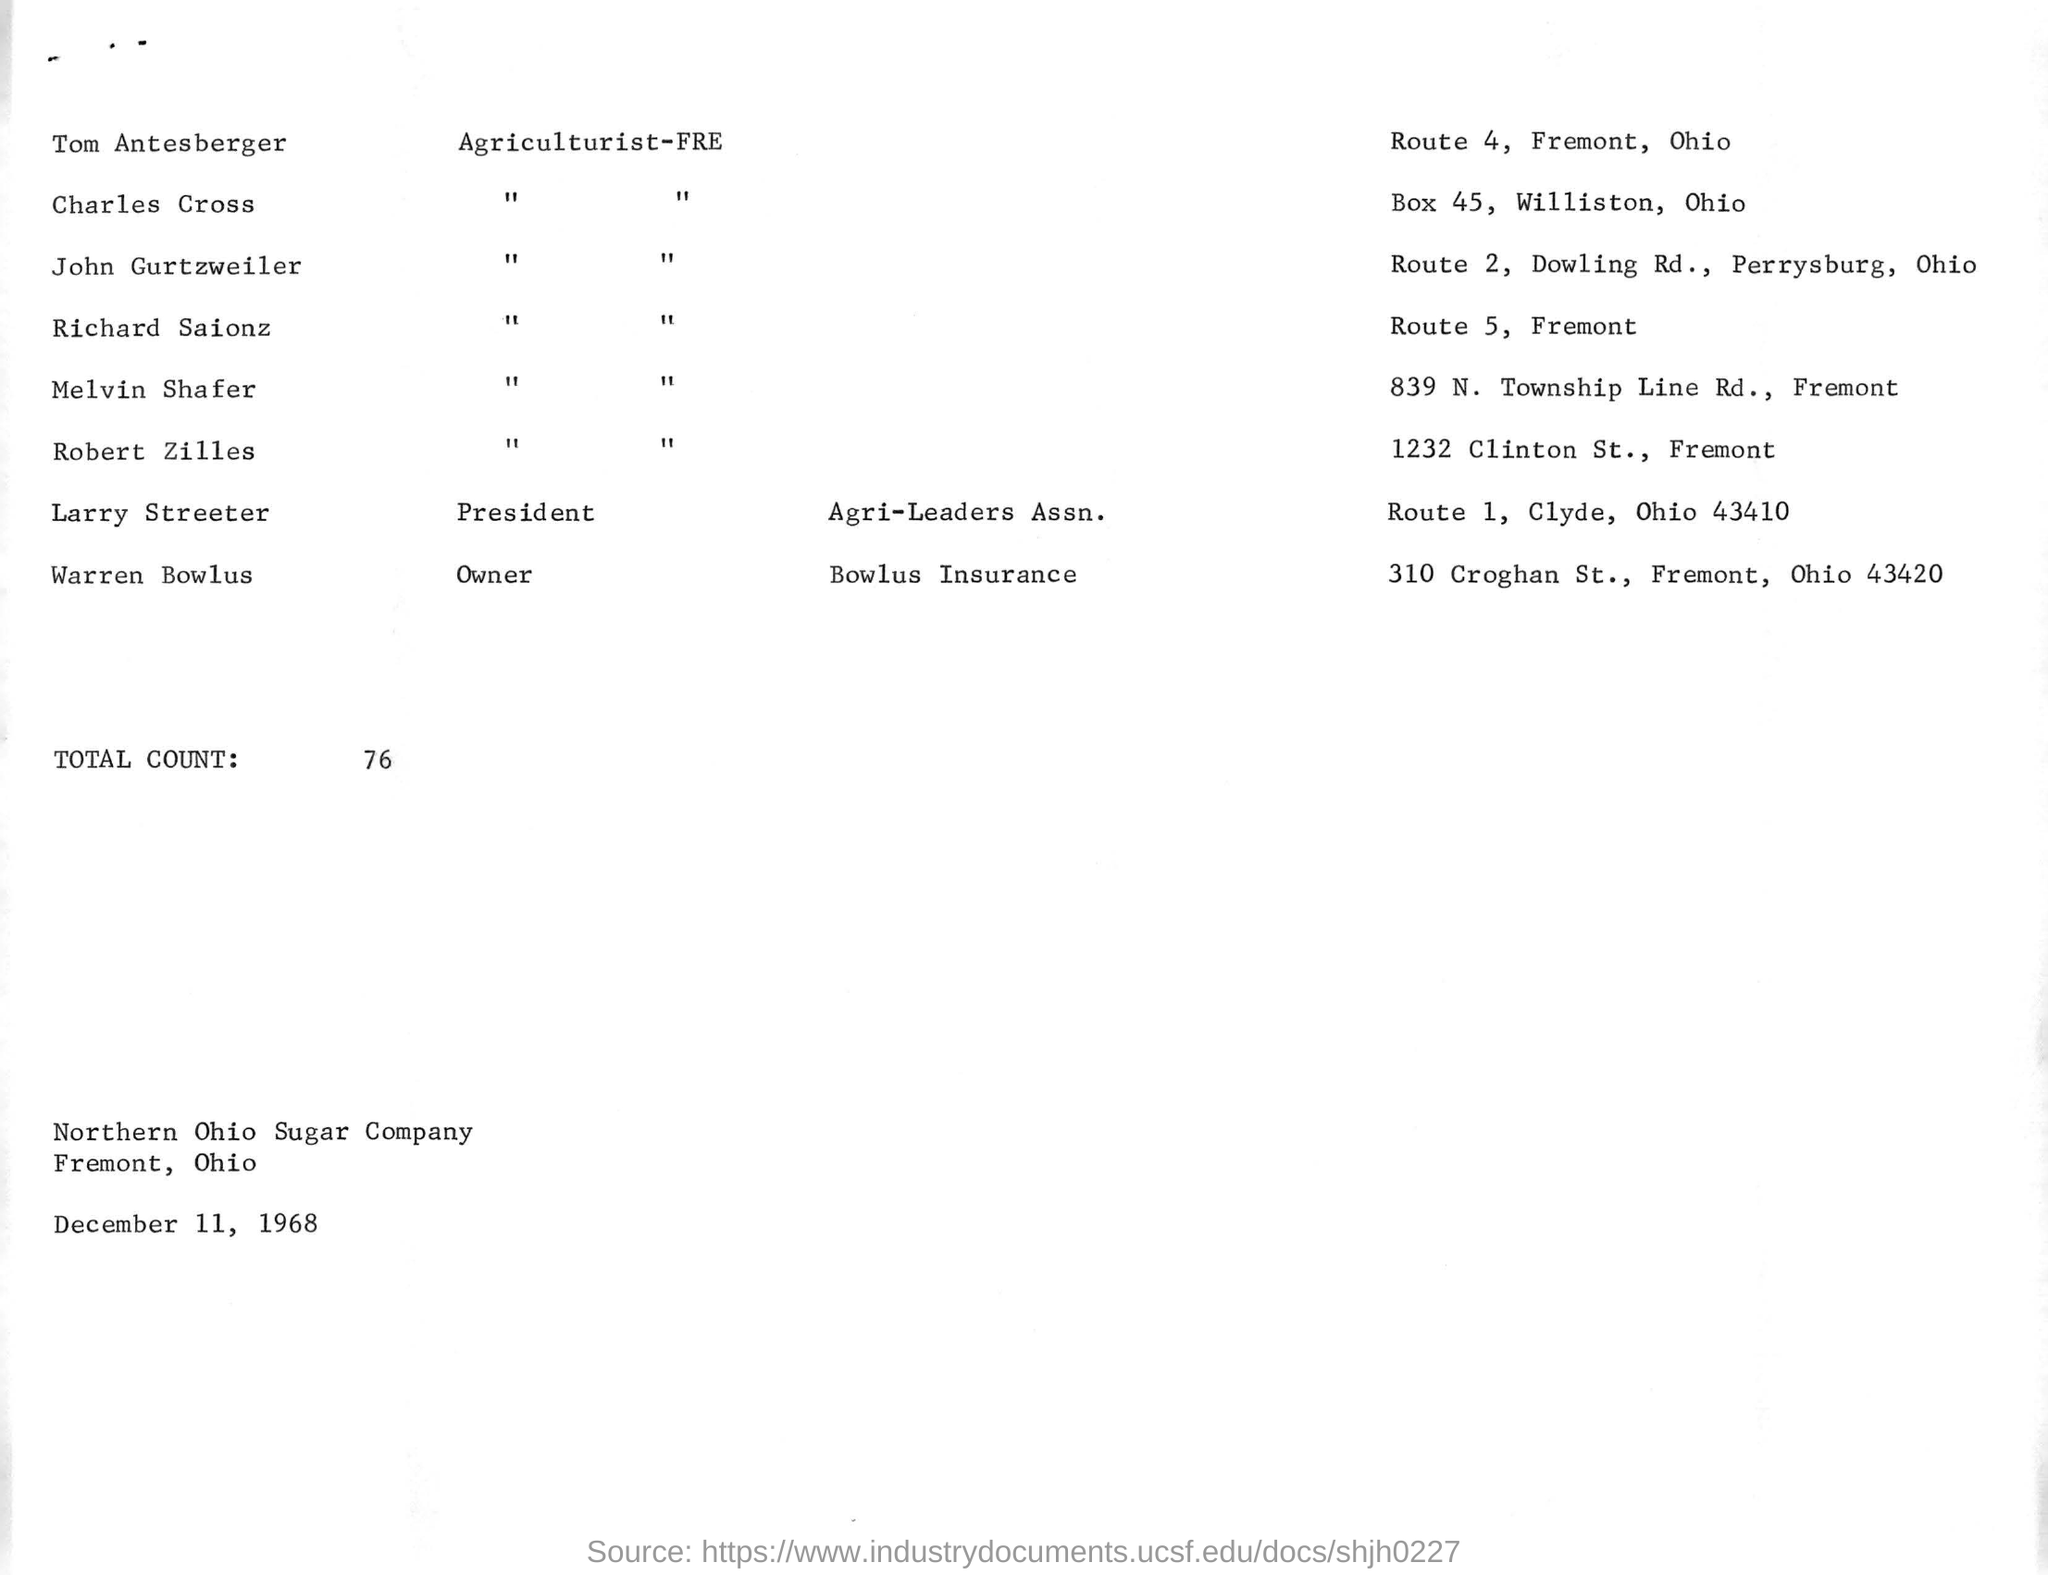What is the total count mentioned ?
Make the answer very short. 76. What is the date mentioned in the given page ?
Your answer should be compact. December 11, 1968. What is the name of the company mentioned ?
Make the answer very short. Northern ohio sugar company. What is the box no. mentioned for charles cross ?
Give a very brief answer. Box 45. What is the route no. mentioned for richard saionz ?
Keep it short and to the point. 5. What is the route no. mentioned for tom antesberger ?
Provide a succinct answer. Route 4. 